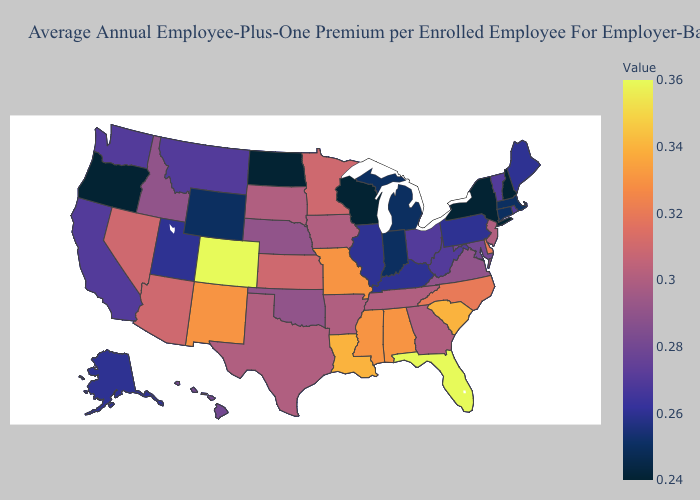Does Hawaii have the lowest value in the West?
Be succinct. No. Among the states that border Florida , does Georgia have the lowest value?
Keep it brief. Yes. Does Wisconsin have the lowest value in the USA?
Short answer required. Yes. Does Colorado have the highest value in the USA?
Quick response, please. Yes. Does the map have missing data?
Be succinct. No. Is the legend a continuous bar?
Answer briefly. Yes. Does Alabama have a lower value than Florida?
Be succinct. Yes. Does North Dakota have the lowest value in the USA?
Answer briefly. Yes. 